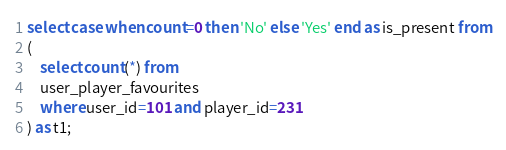Convert code to text. <code><loc_0><loc_0><loc_500><loc_500><_SQL_>select case when count=0 then 'No' else 'Yes' end as is_present from
(
	select count(*) from 
	user_player_favourites 
	where user_id=101 and player_id=231
) as t1;</code> 